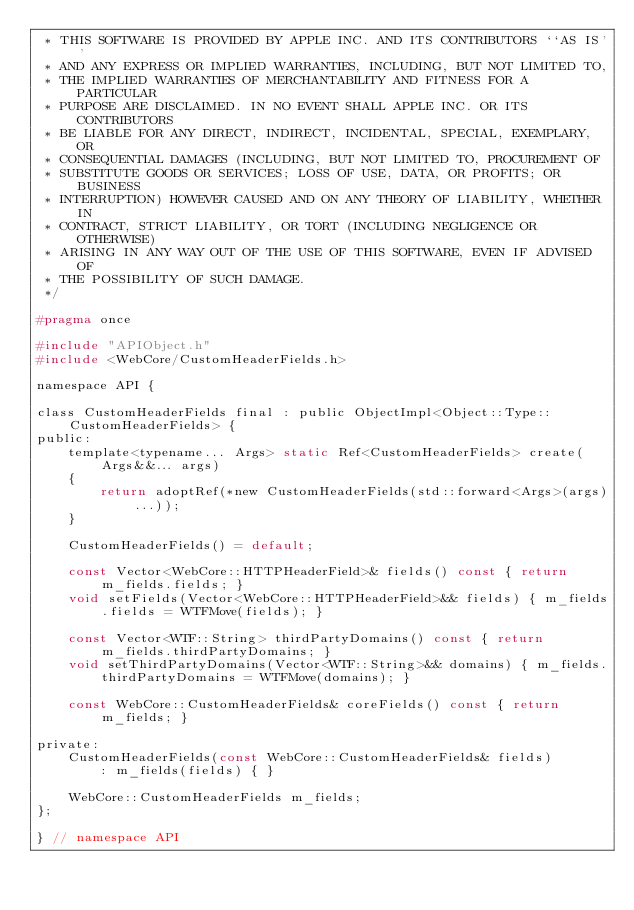<code> <loc_0><loc_0><loc_500><loc_500><_C_> * THIS SOFTWARE IS PROVIDED BY APPLE INC. AND ITS CONTRIBUTORS ``AS IS''
 * AND ANY EXPRESS OR IMPLIED WARRANTIES, INCLUDING, BUT NOT LIMITED TO,
 * THE IMPLIED WARRANTIES OF MERCHANTABILITY AND FITNESS FOR A PARTICULAR
 * PURPOSE ARE DISCLAIMED. IN NO EVENT SHALL APPLE INC. OR ITS CONTRIBUTORS
 * BE LIABLE FOR ANY DIRECT, INDIRECT, INCIDENTAL, SPECIAL, EXEMPLARY, OR
 * CONSEQUENTIAL DAMAGES (INCLUDING, BUT NOT LIMITED TO, PROCUREMENT OF
 * SUBSTITUTE GOODS OR SERVICES; LOSS OF USE, DATA, OR PROFITS; OR BUSINESS
 * INTERRUPTION) HOWEVER CAUSED AND ON ANY THEORY OF LIABILITY, WHETHER IN
 * CONTRACT, STRICT LIABILITY, OR TORT (INCLUDING NEGLIGENCE OR OTHERWISE)
 * ARISING IN ANY WAY OUT OF THE USE OF THIS SOFTWARE, EVEN IF ADVISED OF
 * THE POSSIBILITY OF SUCH DAMAGE.
 */

#pragma once

#include "APIObject.h"
#include <WebCore/CustomHeaderFields.h>

namespace API {

class CustomHeaderFields final : public ObjectImpl<Object::Type::CustomHeaderFields> {
public:
    template<typename... Args> static Ref<CustomHeaderFields> create(Args&&... args)
    {
        return adoptRef(*new CustomHeaderFields(std::forward<Args>(args)...));
    }

    CustomHeaderFields() = default;

    const Vector<WebCore::HTTPHeaderField>& fields() const { return m_fields.fields; }
    void setFields(Vector<WebCore::HTTPHeaderField>&& fields) { m_fields.fields = WTFMove(fields); }

    const Vector<WTF::String> thirdPartyDomains() const { return m_fields.thirdPartyDomains; }
    void setThirdPartyDomains(Vector<WTF::String>&& domains) { m_fields.thirdPartyDomains = WTFMove(domains); }

    const WebCore::CustomHeaderFields& coreFields() const { return m_fields; }

private:
    CustomHeaderFields(const WebCore::CustomHeaderFields& fields)
        : m_fields(fields) { }

    WebCore::CustomHeaderFields m_fields;
};

} // namespace API
</code> 